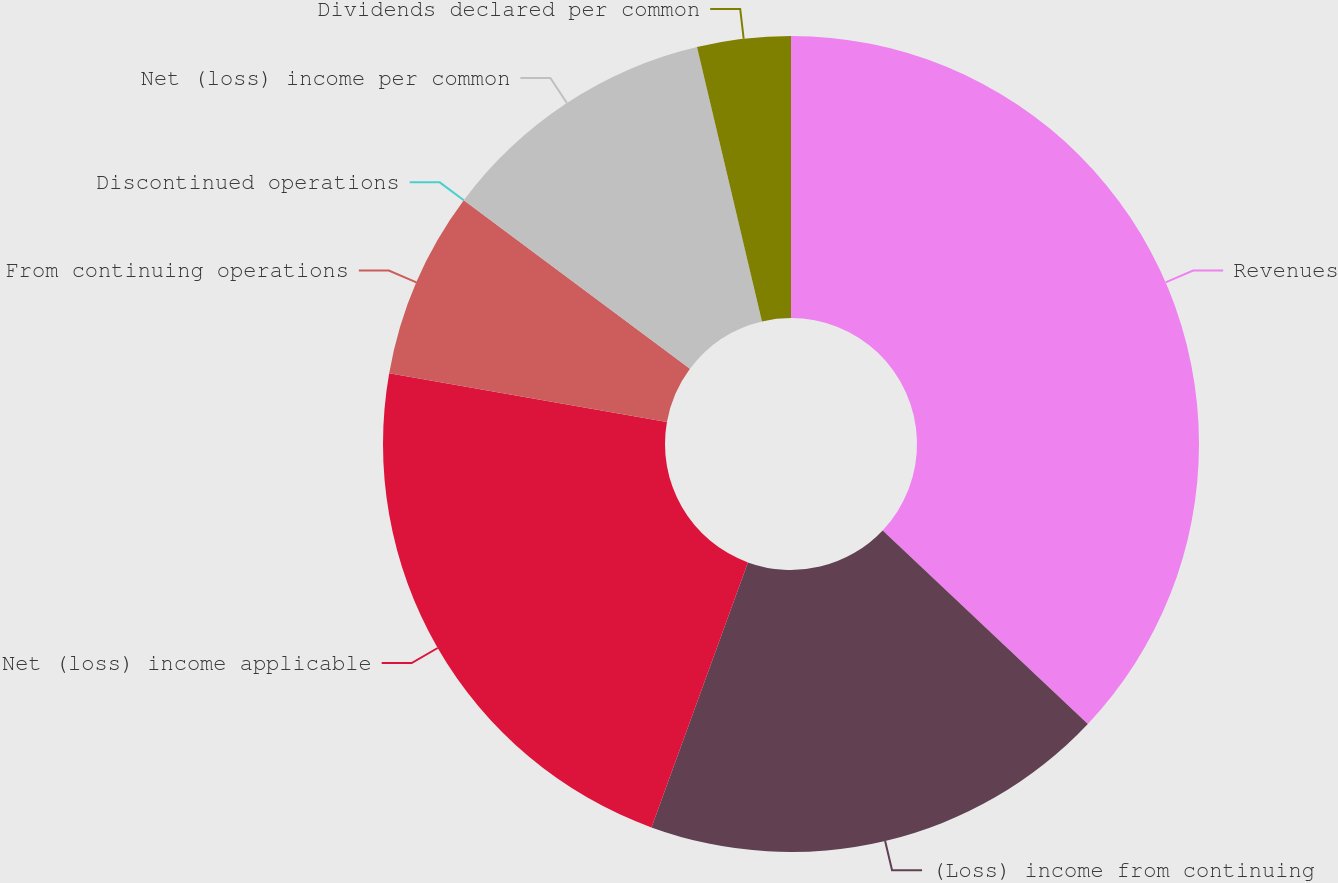<chart> <loc_0><loc_0><loc_500><loc_500><pie_chart><fcel>Revenues<fcel>(Loss) income from continuing<fcel>Net (loss) income applicable<fcel>From continuing operations<fcel>Discontinued operations<fcel>Net (loss) income per common<fcel>Dividends declared per common<nl><fcel>37.03%<fcel>18.52%<fcel>22.22%<fcel>7.41%<fcel>0.0%<fcel>11.11%<fcel>3.7%<nl></chart> 